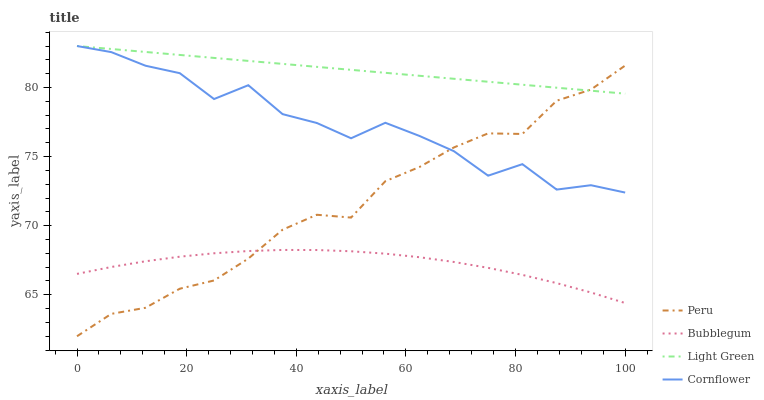Does Bubblegum have the minimum area under the curve?
Answer yes or no. Yes. Does Light Green have the maximum area under the curve?
Answer yes or no. Yes. Does Light Green have the minimum area under the curve?
Answer yes or no. No. Does Bubblegum have the maximum area under the curve?
Answer yes or no. No. Is Light Green the smoothest?
Answer yes or no. Yes. Is Cornflower the roughest?
Answer yes or no. Yes. Is Bubblegum the smoothest?
Answer yes or no. No. Is Bubblegum the roughest?
Answer yes or no. No. Does Peru have the lowest value?
Answer yes or no. Yes. Does Bubblegum have the lowest value?
Answer yes or no. No. Does Light Green have the highest value?
Answer yes or no. Yes. Does Bubblegum have the highest value?
Answer yes or no. No. Is Bubblegum less than Light Green?
Answer yes or no. Yes. Is Light Green greater than Bubblegum?
Answer yes or no. Yes. Does Bubblegum intersect Peru?
Answer yes or no. Yes. Is Bubblegum less than Peru?
Answer yes or no. No. Is Bubblegum greater than Peru?
Answer yes or no. No. Does Bubblegum intersect Light Green?
Answer yes or no. No. 